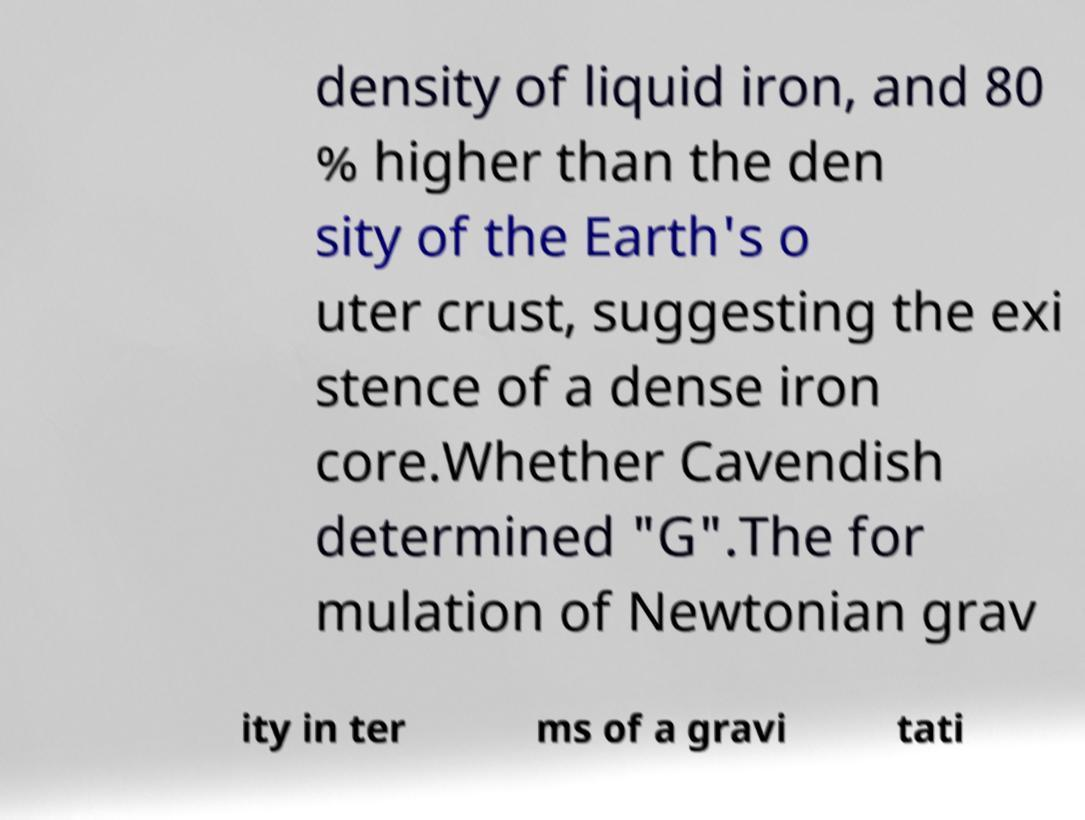There's text embedded in this image that I need extracted. Can you transcribe it verbatim? density of liquid iron, and 80 % higher than the den sity of the Earth's o uter crust, suggesting the exi stence of a dense iron core.Whether Cavendish determined "G".The for mulation of Newtonian grav ity in ter ms of a gravi tati 